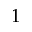<formula> <loc_0><loc_0><loc_500><loc_500>1</formula> 